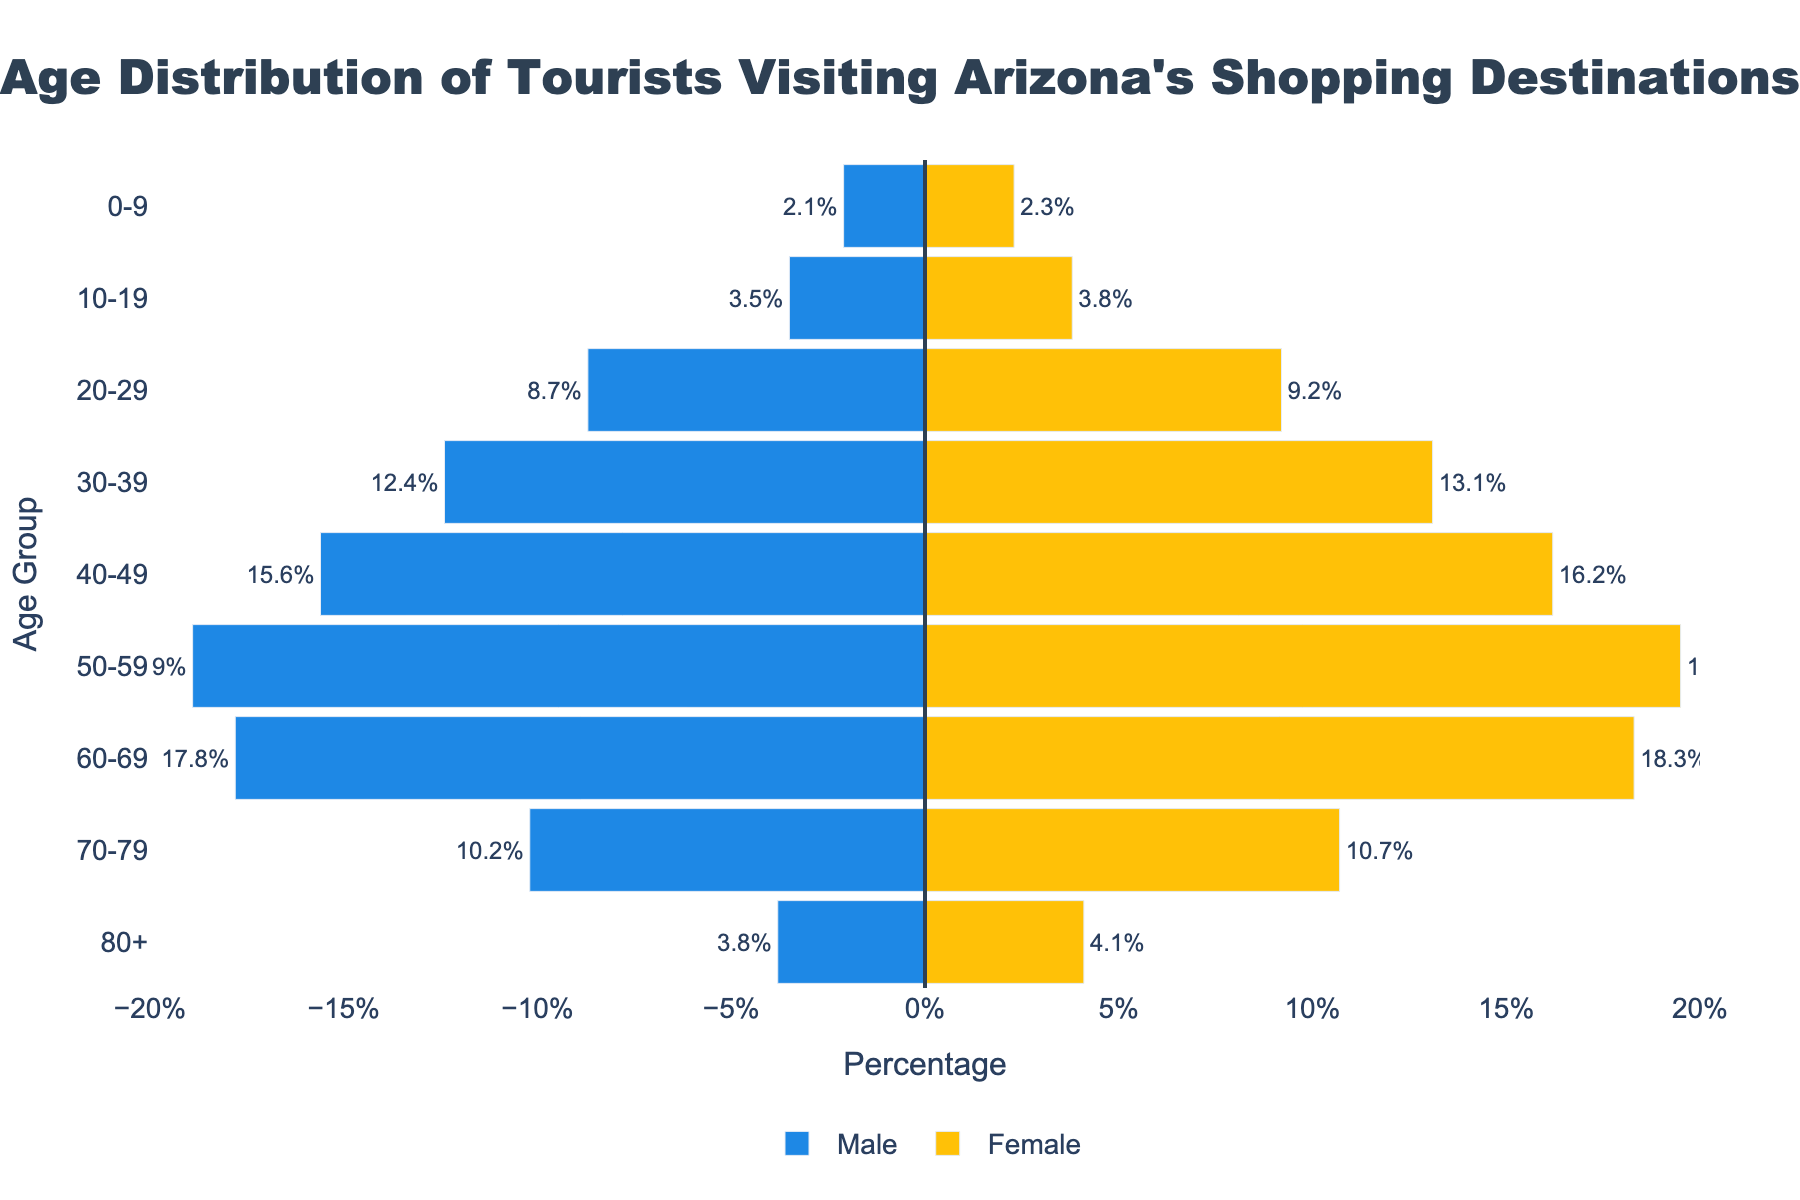What is the title of the figure? The title is displayed prominently at the top of the figure. It reads: "Age Distribution of Tourists Visiting Arizona's Shopping Destinations."
Answer: Age Distribution of Tourists Visiting Arizona's Shopping Destinations How many age groups are represented in the figure? Count the distinct age group labels on the y-axis of the figure. There are 9 distinct age groups listed.
Answer: 9 Which age group has the highest percentage of female tourists? Look for the longest yellow bar on the female side of the pyramid. The attached label shows the age group is 50-59 years with a percentage of 19.5%.
Answer: 50-59 What percentage of male tourists are in the 20-29 age group? On the male side (blue bars), find the horizontal bar corresponding to the 20-29 age group and note the text label which indicates 8.7%.
Answer: 8.7% What is the difference in the percentage of female tourists between the 40-49 and 30-39 age groups? Identify the lengths of the yellow bars for the 40-49 (16.2%) and 30-39 (13.1%) age groups. Subtract the smaller percentage from the larger one: 16.2 - 13.1 = 3.1%.
Answer: 3.1% Which gender has a higher percentage of tourists in the 0-9 age group? Compare the length of the bars for the 0-9 age group: the female bar (yellow) is 2.3% and the male bar (blue) is 2.1%. Hence, females have a higher percentage.
Answer: Female In the 60-69 age group, what is the combined percentage of male and female tourists? Add the values from both the male and female bars in the 60-69 age group: 17.8% (male) + 18.3% (female) = 36.1%.
Answer: 36.1% How does the percentage of male tourists in the 70-79 age group compare to that in the 10-19 age group? The male bar for ages 70-79 is 10.2%, while for ages 10-19, it is 3.5%. Therefore, there are more male tourists in the 70-79 age group compared to the 10-19 age group.
Answer: The 70-79 age group has a higher percentage 